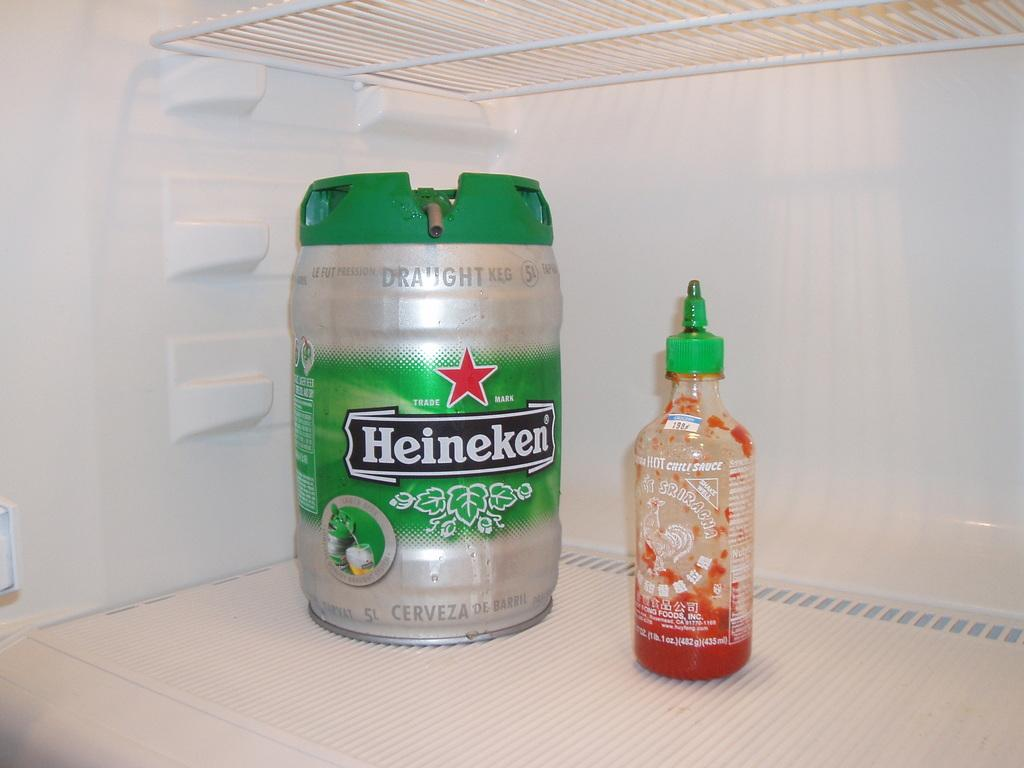Provide a one-sentence caption for the provided image. A keg of Heineken in a fridge next to a sauce bottle. 